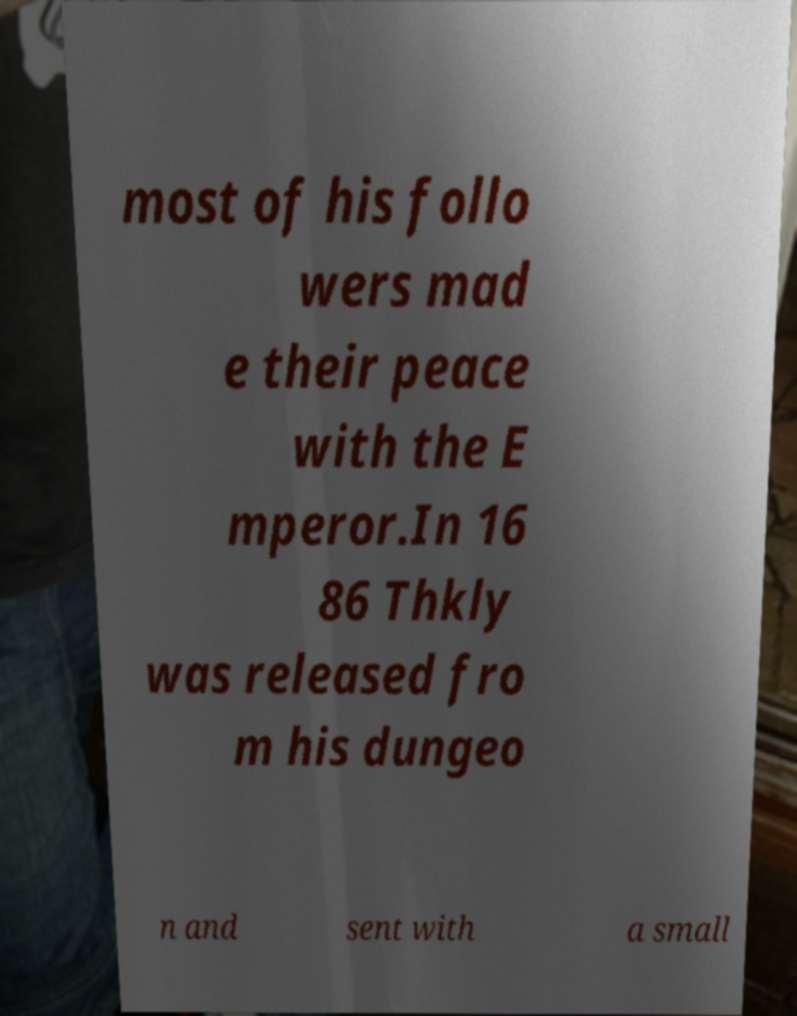Please read and relay the text visible in this image. What does it say? most of his follo wers mad e their peace with the E mperor.In 16 86 Thkly was released fro m his dungeo n and sent with a small 